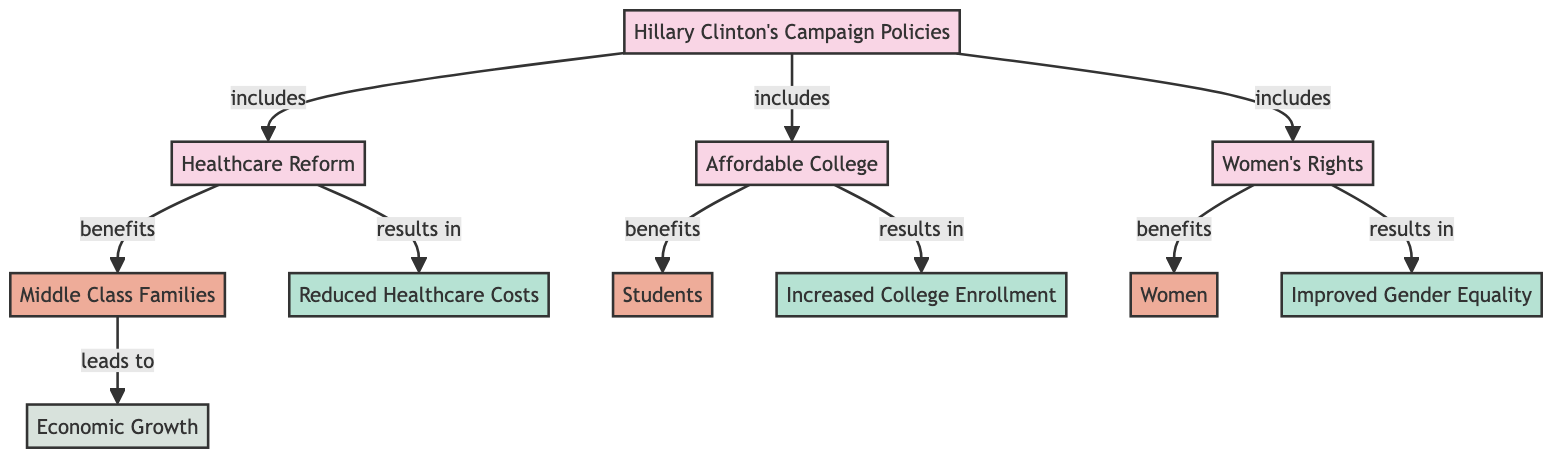What are the three main policies from Hillary Clinton's campaign illustrated in the diagram? The diagram indicates three main policies: Healthcare Reform, Affordable College, and Women's Rights, which are directly connected to Hillary Clinton's Campaign Policies node.
Answer: Healthcare Reform, Affordable College, Women's Rights How many demographic groups are represented in the diagram? There are three demographic groups in the diagram: Middle Class Families, Students, and Women, indicated as nodes branching from the policies.
Answer: Three What is the benefit resulting from the Healthcare Reform policy? The Healthcare Reform policy specifically leads to Reduced Healthcare Costs as shown by the arrow connection from Healthcare Reform to Reduced Healthcare Costs in the diagram.
Answer: Reduced Healthcare Costs Which demographic benefits from the Affordable College policy? The Affordable College policy benefits Students, as indicated by the connection from Affordable College to Students in the diagram.
Answer: Students What outcome is associated with Middle Class Families in the flowchart? Middle Class Families lead to Economic Growth, according to the flow of the diagram which connects Middle Class Families to Economic Growth.
Answer: Economic Growth What is the first node that connects to Women's Rights? The first node connected to Women's Rights is the Women's Rights policy itself, as shown in the diagram where it originates.
Answer: Women's Rights Which benefit is linked to the policy on Women's Rights? The diagram shows that the Women's Rights policy results in Improved Gender Equality, establishing a direct relationship between the policy and this benefit.
Answer: Improved Gender Equality If Healthcare Reform and Women's Rights are implemented, what can be expected? Implementing Healthcare Reform leads to Reduced Healthcare Costs, while Women's Rights results in Improved Gender Equality; thus, both policies should yield increased social and economic benefits.
Answer: Reduced Healthcare Costs, Improved Gender Equality What kind of diagram is illustrated here? The diagram shows the flow of policies and their social and economic impacts, making it a Policy Impact Flowchart.
Answer: Policy Impact Flowchart 